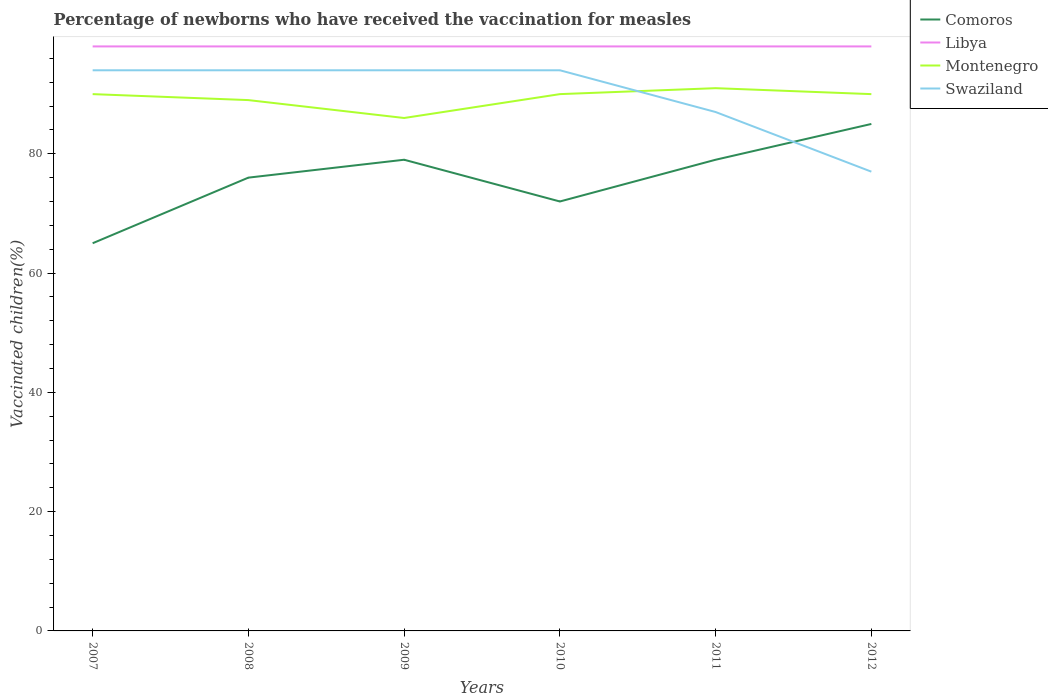How many different coloured lines are there?
Your response must be concise. 4. Across all years, what is the maximum percentage of vaccinated children in Montenegro?
Provide a short and direct response. 86. What is the total percentage of vaccinated children in Libya in the graph?
Your answer should be very brief. 0. What is the difference between the highest and the lowest percentage of vaccinated children in Montenegro?
Make the answer very short. 4. Is the percentage of vaccinated children in Montenegro strictly greater than the percentage of vaccinated children in Comoros over the years?
Provide a short and direct response. No. How many lines are there?
Make the answer very short. 4. How many years are there in the graph?
Provide a short and direct response. 6. What is the difference between two consecutive major ticks on the Y-axis?
Make the answer very short. 20. Are the values on the major ticks of Y-axis written in scientific E-notation?
Your answer should be very brief. No. Where does the legend appear in the graph?
Provide a succinct answer. Top right. How many legend labels are there?
Your response must be concise. 4. What is the title of the graph?
Provide a succinct answer. Percentage of newborns who have received the vaccination for measles. Does "Kiribati" appear as one of the legend labels in the graph?
Ensure brevity in your answer.  No. What is the label or title of the X-axis?
Offer a very short reply. Years. What is the label or title of the Y-axis?
Make the answer very short. Vaccinated children(%). What is the Vaccinated children(%) in Comoros in 2007?
Your answer should be very brief. 65. What is the Vaccinated children(%) in Libya in 2007?
Offer a terse response. 98. What is the Vaccinated children(%) of Swaziland in 2007?
Keep it short and to the point. 94. What is the Vaccinated children(%) in Montenegro in 2008?
Ensure brevity in your answer.  89. What is the Vaccinated children(%) in Swaziland in 2008?
Your response must be concise. 94. What is the Vaccinated children(%) in Comoros in 2009?
Your response must be concise. 79. What is the Vaccinated children(%) in Montenegro in 2009?
Your response must be concise. 86. What is the Vaccinated children(%) of Swaziland in 2009?
Your response must be concise. 94. What is the Vaccinated children(%) of Montenegro in 2010?
Offer a very short reply. 90. What is the Vaccinated children(%) in Swaziland in 2010?
Ensure brevity in your answer.  94. What is the Vaccinated children(%) of Comoros in 2011?
Your answer should be very brief. 79. What is the Vaccinated children(%) in Libya in 2011?
Give a very brief answer. 98. What is the Vaccinated children(%) in Montenegro in 2011?
Offer a terse response. 91. What is the Vaccinated children(%) of Swaziland in 2011?
Offer a terse response. 87. What is the Vaccinated children(%) in Comoros in 2012?
Offer a terse response. 85. What is the Vaccinated children(%) of Montenegro in 2012?
Provide a short and direct response. 90. Across all years, what is the maximum Vaccinated children(%) in Comoros?
Your response must be concise. 85. Across all years, what is the maximum Vaccinated children(%) in Montenegro?
Offer a terse response. 91. Across all years, what is the maximum Vaccinated children(%) in Swaziland?
Give a very brief answer. 94. Across all years, what is the minimum Vaccinated children(%) of Comoros?
Your response must be concise. 65. Across all years, what is the minimum Vaccinated children(%) of Libya?
Offer a terse response. 98. Across all years, what is the minimum Vaccinated children(%) of Montenegro?
Your response must be concise. 86. What is the total Vaccinated children(%) of Comoros in the graph?
Keep it short and to the point. 456. What is the total Vaccinated children(%) in Libya in the graph?
Your answer should be very brief. 588. What is the total Vaccinated children(%) in Montenegro in the graph?
Offer a very short reply. 536. What is the total Vaccinated children(%) of Swaziland in the graph?
Your answer should be compact. 540. What is the difference between the Vaccinated children(%) of Libya in 2007 and that in 2008?
Offer a very short reply. 0. What is the difference between the Vaccinated children(%) of Montenegro in 2007 and that in 2008?
Provide a short and direct response. 1. What is the difference between the Vaccinated children(%) of Libya in 2007 and that in 2009?
Provide a succinct answer. 0. What is the difference between the Vaccinated children(%) in Comoros in 2007 and that in 2011?
Your response must be concise. -14. What is the difference between the Vaccinated children(%) of Libya in 2007 and that in 2011?
Provide a succinct answer. 0. What is the difference between the Vaccinated children(%) in Swaziland in 2007 and that in 2011?
Your answer should be very brief. 7. What is the difference between the Vaccinated children(%) of Libya in 2007 and that in 2012?
Your answer should be very brief. 0. What is the difference between the Vaccinated children(%) in Montenegro in 2007 and that in 2012?
Make the answer very short. 0. What is the difference between the Vaccinated children(%) in Comoros in 2008 and that in 2009?
Make the answer very short. -3. What is the difference between the Vaccinated children(%) in Libya in 2008 and that in 2009?
Keep it short and to the point. 0. What is the difference between the Vaccinated children(%) of Montenegro in 2008 and that in 2009?
Offer a very short reply. 3. What is the difference between the Vaccinated children(%) of Swaziland in 2008 and that in 2009?
Provide a short and direct response. 0. What is the difference between the Vaccinated children(%) of Libya in 2008 and that in 2010?
Offer a terse response. 0. What is the difference between the Vaccinated children(%) of Montenegro in 2008 and that in 2010?
Make the answer very short. -1. What is the difference between the Vaccinated children(%) in Montenegro in 2008 and that in 2011?
Your answer should be compact. -2. What is the difference between the Vaccinated children(%) in Swaziland in 2008 and that in 2011?
Make the answer very short. 7. What is the difference between the Vaccinated children(%) of Libya in 2008 and that in 2012?
Provide a short and direct response. 0. What is the difference between the Vaccinated children(%) in Montenegro in 2008 and that in 2012?
Keep it short and to the point. -1. What is the difference between the Vaccinated children(%) in Libya in 2009 and that in 2010?
Provide a short and direct response. 0. What is the difference between the Vaccinated children(%) of Montenegro in 2009 and that in 2010?
Offer a terse response. -4. What is the difference between the Vaccinated children(%) of Swaziland in 2009 and that in 2010?
Make the answer very short. 0. What is the difference between the Vaccinated children(%) of Comoros in 2009 and that in 2011?
Your answer should be compact. 0. What is the difference between the Vaccinated children(%) of Libya in 2009 and that in 2011?
Provide a short and direct response. 0. What is the difference between the Vaccinated children(%) of Montenegro in 2009 and that in 2011?
Your answer should be very brief. -5. What is the difference between the Vaccinated children(%) in Montenegro in 2009 and that in 2012?
Keep it short and to the point. -4. What is the difference between the Vaccinated children(%) of Comoros in 2010 and that in 2011?
Offer a very short reply. -7. What is the difference between the Vaccinated children(%) in Libya in 2010 and that in 2011?
Your answer should be compact. 0. What is the difference between the Vaccinated children(%) of Swaziland in 2010 and that in 2012?
Keep it short and to the point. 17. What is the difference between the Vaccinated children(%) in Libya in 2011 and that in 2012?
Give a very brief answer. 0. What is the difference between the Vaccinated children(%) in Montenegro in 2011 and that in 2012?
Offer a terse response. 1. What is the difference between the Vaccinated children(%) of Swaziland in 2011 and that in 2012?
Your response must be concise. 10. What is the difference between the Vaccinated children(%) of Comoros in 2007 and the Vaccinated children(%) of Libya in 2008?
Your answer should be compact. -33. What is the difference between the Vaccinated children(%) of Comoros in 2007 and the Vaccinated children(%) of Montenegro in 2008?
Keep it short and to the point. -24. What is the difference between the Vaccinated children(%) in Comoros in 2007 and the Vaccinated children(%) in Swaziland in 2008?
Offer a terse response. -29. What is the difference between the Vaccinated children(%) in Libya in 2007 and the Vaccinated children(%) in Swaziland in 2008?
Make the answer very short. 4. What is the difference between the Vaccinated children(%) of Montenegro in 2007 and the Vaccinated children(%) of Swaziland in 2008?
Provide a short and direct response. -4. What is the difference between the Vaccinated children(%) in Comoros in 2007 and the Vaccinated children(%) in Libya in 2009?
Your answer should be compact. -33. What is the difference between the Vaccinated children(%) of Comoros in 2007 and the Vaccinated children(%) of Montenegro in 2009?
Keep it short and to the point. -21. What is the difference between the Vaccinated children(%) in Comoros in 2007 and the Vaccinated children(%) in Libya in 2010?
Ensure brevity in your answer.  -33. What is the difference between the Vaccinated children(%) in Comoros in 2007 and the Vaccinated children(%) in Montenegro in 2010?
Provide a short and direct response. -25. What is the difference between the Vaccinated children(%) in Comoros in 2007 and the Vaccinated children(%) in Swaziland in 2010?
Offer a very short reply. -29. What is the difference between the Vaccinated children(%) of Libya in 2007 and the Vaccinated children(%) of Swaziland in 2010?
Your response must be concise. 4. What is the difference between the Vaccinated children(%) of Montenegro in 2007 and the Vaccinated children(%) of Swaziland in 2010?
Provide a short and direct response. -4. What is the difference between the Vaccinated children(%) of Comoros in 2007 and the Vaccinated children(%) of Libya in 2011?
Your answer should be very brief. -33. What is the difference between the Vaccinated children(%) in Comoros in 2007 and the Vaccinated children(%) in Swaziland in 2011?
Your response must be concise. -22. What is the difference between the Vaccinated children(%) of Libya in 2007 and the Vaccinated children(%) of Swaziland in 2011?
Keep it short and to the point. 11. What is the difference between the Vaccinated children(%) in Montenegro in 2007 and the Vaccinated children(%) in Swaziland in 2011?
Give a very brief answer. 3. What is the difference between the Vaccinated children(%) in Comoros in 2007 and the Vaccinated children(%) in Libya in 2012?
Make the answer very short. -33. What is the difference between the Vaccinated children(%) in Comoros in 2007 and the Vaccinated children(%) in Swaziland in 2012?
Provide a succinct answer. -12. What is the difference between the Vaccinated children(%) of Libya in 2007 and the Vaccinated children(%) of Montenegro in 2012?
Provide a short and direct response. 8. What is the difference between the Vaccinated children(%) in Libya in 2008 and the Vaccinated children(%) in Montenegro in 2009?
Provide a short and direct response. 12. What is the difference between the Vaccinated children(%) in Libya in 2008 and the Vaccinated children(%) in Swaziland in 2009?
Your answer should be compact. 4. What is the difference between the Vaccinated children(%) in Montenegro in 2008 and the Vaccinated children(%) in Swaziland in 2009?
Offer a terse response. -5. What is the difference between the Vaccinated children(%) of Comoros in 2008 and the Vaccinated children(%) of Montenegro in 2010?
Your response must be concise. -14. What is the difference between the Vaccinated children(%) in Libya in 2008 and the Vaccinated children(%) in Montenegro in 2010?
Keep it short and to the point. 8. What is the difference between the Vaccinated children(%) of Montenegro in 2008 and the Vaccinated children(%) of Swaziland in 2010?
Offer a very short reply. -5. What is the difference between the Vaccinated children(%) of Comoros in 2008 and the Vaccinated children(%) of Libya in 2011?
Your response must be concise. -22. What is the difference between the Vaccinated children(%) of Comoros in 2008 and the Vaccinated children(%) of Swaziland in 2011?
Provide a short and direct response. -11. What is the difference between the Vaccinated children(%) in Libya in 2008 and the Vaccinated children(%) in Montenegro in 2011?
Your response must be concise. 7. What is the difference between the Vaccinated children(%) in Libya in 2008 and the Vaccinated children(%) in Swaziland in 2011?
Your response must be concise. 11. What is the difference between the Vaccinated children(%) in Montenegro in 2008 and the Vaccinated children(%) in Swaziland in 2011?
Your response must be concise. 2. What is the difference between the Vaccinated children(%) of Comoros in 2008 and the Vaccinated children(%) of Libya in 2012?
Your answer should be very brief. -22. What is the difference between the Vaccinated children(%) of Comoros in 2008 and the Vaccinated children(%) of Montenegro in 2012?
Offer a very short reply. -14. What is the difference between the Vaccinated children(%) of Montenegro in 2008 and the Vaccinated children(%) of Swaziland in 2012?
Your response must be concise. 12. What is the difference between the Vaccinated children(%) in Comoros in 2009 and the Vaccinated children(%) in Libya in 2010?
Ensure brevity in your answer.  -19. What is the difference between the Vaccinated children(%) of Comoros in 2009 and the Vaccinated children(%) of Swaziland in 2010?
Provide a short and direct response. -15. What is the difference between the Vaccinated children(%) in Libya in 2009 and the Vaccinated children(%) in Swaziland in 2010?
Make the answer very short. 4. What is the difference between the Vaccinated children(%) in Comoros in 2009 and the Vaccinated children(%) in Libya in 2011?
Keep it short and to the point. -19. What is the difference between the Vaccinated children(%) of Comoros in 2009 and the Vaccinated children(%) of Swaziland in 2011?
Offer a terse response. -8. What is the difference between the Vaccinated children(%) of Libya in 2009 and the Vaccinated children(%) of Montenegro in 2011?
Make the answer very short. 7. What is the difference between the Vaccinated children(%) in Libya in 2009 and the Vaccinated children(%) in Swaziland in 2011?
Provide a succinct answer. 11. What is the difference between the Vaccinated children(%) of Montenegro in 2009 and the Vaccinated children(%) of Swaziland in 2011?
Your response must be concise. -1. What is the difference between the Vaccinated children(%) of Comoros in 2009 and the Vaccinated children(%) of Libya in 2012?
Your answer should be very brief. -19. What is the difference between the Vaccinated children(%) of Comoros in 2009 and the Vaccinated children(%) of Swaziland in 2012?
Give a very brief answer. 2. What is the difference between the Vaccinated children(%) in Libya in 2009 and the Vaccinated children(%) in Montenegro in 2012?
Your answer should be compact. 8. What is the difference between the Vaccinated children(%) in Montenegro in 2009 and the Vaccinated children(%) in Swaziland in 2012?
Provide a succinct answer. 9. What is the difference between the Vaccinated children(%) of Comoros in 2010 and the Vaccinated children(%) of Libya in 2011?
Your answer should be very brief. -26. What is the difference between the Vaccinated children(%) of Comoros in 2010 and the Vaccinated children(%) of Montenegro in 2011?
Ensure brevity in your answer.  -19. What is the difference between the Vaccinated children(%) of Comoros in 2010 and the Vaccinated children(%) of Libya in 2012?
Provide a succinct answer. -26. What is the difference between the Vaccinated children(%) of Comoros in 2010 and the Vaccinated children(%) of Swaziland in 2012?
Your answer should be very brief. -5. What is the difference between the Vaccinated children(%) in Libya in 2010 and the Vaccinated children(%) in Montenegro in 2012?
Ensure brevity in your answer.  8. What is the difference between the Vaccinated children(%) in Comoros in 2011 and the Vaccinated children(%) in Libya in 2012?
Your answer should be very brief. -19. What is the difference between the Vaccinated children(%) of Comoros in 2011 and the Vaccinated children(%) of Swaziland in 2012?
Your answer should be compact. 2. What is the difference between the Vaccinated children(%) in Libya in 2011 and the Vaccinated children(%) in Montenegro in 2012?
Provide a succinct answer. 8. What is the difference between the Vaccinated children(%) in Libya in 2011 and the Vaccinated children(%) in Swaziland in 2012?
Give a very brief answer. 21. What is the difference between the Vaccinated children(%) in Montenegro in 2011 and the Vaccinated children(%) in Swaziland in 2012?
Provide a succinct answer. 14. What is the average Vaccinated children(%) of Libya per year?
Give a very brief answer. 98. What is the average Vaccinated children(%) in Montenegro per year?
Your answer should be very brief. 89.33. In the year 2007, what is the difference between the Vaccinated children(%) of Comoros and Vaccinated children(%) of Libya?
Provide a succinct answer. -33. In the year 2007, what is the difference between the Vaccinated children(%) of Comoros and Vaccinated children(%) of Montenegro?
Keep it short and to the point. -25. In the year 2007, what is the difference between the Vaccinated children(%) in Montenegro and Vaccinated children(%) in Swaziland?
Your response must be concise. -4. In the year 2008, what is the difference between the Vaccinated children(%) of Libya and Vaccinated children(%) of Montenegro?
Your answer should be compact. 9. In the year 2008, what is the difference between the Vaccinated children(%) of Libya and Vaccinated children(%) of Swaziland?
Your answer should be compact. 4. In the year 2008, what is the difference between the Vaccinated children(%) in Montenegro and Vaccinated children(%) in Swaziland?
Offer a very short reply. -5. In the year 2009, what is the difference between the Vaccinated children(%) of Comoros and Vaccinated children(%) of Libya?
Provide a short and direct response. -19. In the year 2009, what is the difference between the Vaccinated children(%) in Comoros and Vaccinated children(%) in Montenegro?
Offer a terse response. -7. In the year 2009, what is the difference between the Vaccinated children(%) of Comoros and Vaccinated children(%) of Swaziland?
Make the answer very short. -15. In the year 2009, what is the difference between the Vaccinated children(%) in Montenegro and Vaccinated children(%) in Swaziland?
Your answer should be very brief. -8. In the year 2010, what is the difference between the Vaccinated children(%) of Comoros and Vaccinated children(%) of Libya?
Your answer should be very brief. -26. In the year 2010, what is the difference between the Vaccinated children(%) of Comoros and Vaccinated children(%) of Swaziland?
Keep it short and to the point. -22. In the year 2010, what is the difference between the Vaccinated children(%) of Montenegro and Vaccinated children(%) of Swaziland?
Offer a terse response. -4. In the year 2011, what is the difference between the Vaccinated children(%) in Comoros and Vaccinated children(%) in Montenegro?
Offer a very short reply. -12. In the year 2011, what is the difference between the Vaccinated children(%) in Libya and Vaccinated children(%) in Montenegro?
Your response must be concise. 7. In the year 2011, what is the difference between the Vaccinated children(%) of Libya and Vaccinated children(%) of Swaziland?
Provide a short and direct response. 11. In the year 2011, what is the difference between the Vaccinated children(%) in Montenegro and Vaccinated children(%) in Swaziland?
Provide a short and direct response. 4. In the year 2012, what is the difference between the Vaccinated children(%) of Comoros and Vaccinated children(%) of Libya?
Provide a succinct answer. -13. In the year 2012, what is the difference between the Vaccinated children(%) of Comoros and Vaccinated children(%) of Montenegro?
Offer a very short reply. -5. In the year 2012, what is the difference between the Vaccinated children(%) in Libya and Vaccinated children(%) in Montenegro?
Offer a very short reply. 8. What is the ratio of the Vaccinated children(%) of Comoros in 2007 to that in 2008?
Make the answer very short. 0.86. What is the ratio of the Vaccinated children(%) of Libya in 2007 to that in 2008?
Offer a terse response. 1. What is the ratio of the Vaccinated children(%) in Montenegro in 2007 to that in 2008?
Keep it short and to the point. 1.01. What is the ratio of the Vaccinated children(%) in Comoros in 2007 to that in 2009?
Provide a succinct answer. 0.82. What is the ratio of the Vaccinated children(%) in Montenegro in 2007 to that in 2009?
Provide a succinct answer. 1.05. What is the ratio of the Vaccinated children(%) in Swaziland in 2007 to that in 2009?
Your response must be concise. 1. What is the ratio of the Vaccinated children(%) in Comoros in 2007 to that in 2010?
Provide a short and direct response. 0.9. What is the ratio of the Vaccinated children(%) in Comoros in 2007 to that in 2011?
Your response must be concise. 0.82. What is the ratio of the Vaccinated children(%) of Swaziland in 2007 to that in 2011?
Your answer should be very brief. 1.08. What is the ratio of the Vaccinated children(%) in Comoros in 2007 to that in 2012?
Your answer should be very brief. 0.76. What is the ratio of the Vaccinated children(%) of Swaziland in 2007 to that in 2012?
Your answer should be very brief. 1.22. What is the ratio of the Vaccinated children(%) of Comoros in 2008 to that in 2009?
Offer a very short reply. 0.96. What is the ratio of the Vaccinated children(%) of Libya in 2008 to that in 2009?
Your answer should be very brief. 1. What is the ratio of the Vaccinated children(%) of Montenegro in 2008 to that in 2009?
Offer a terse response. 1.03. What is the ratio of the Vaccinated children(%) of Swaziland in 2008 to that in 2009?
Offer a very short reply. 1. What is the ratio of the Vaccinated children(%) in Comoros in 2008 to that in 2010?
Provide a succinct answer. 1.06. What is the ratio of the Vaccinated children(%) of Montenegro in 2008 to that in 2010?
Keep it short and to the point. 0.99. What is the ratio of the Vaccinated children(%) of Libya in 2008 to that in 2011?
Your response must be concise. 1. What is the ratio of the Vaccinated children(%) of Swaziland in 2008 to that in 2011?
Your response must be concise. 1.08. What is the ratio of the Vaccinated children(%) of Comoros in 2008 to that in 2012?
Offer a terse response. 0.89. What is the ratio of the Vaccinated children(%) in Montenegro in 2008 to that in 2012?
Give a very brief answer. 0.99. What is the ratio of the Vaccinated children(%) in Swaziland in 2008 to that in 2012?
Provide a short and direct response. 1.22. What is the ratio of the Vaccinated children(%) in Comoros in 2009 to that in 2010?
Your response must be concise. 1.1. What is the ratio of the Vaccinated children(%) in Libya in 2009 to that in 2010?
Make the answer very short. 1. What is the ratio of the Vaccinated children(%) in Montenegro in 2009 to that in 2010?
Your response must be concise. 0.96. What is the ratio of the Vaccinated children(%) of Libya in 2009 to that in 2011?
Offer a terse response. 1. What is the ratio of the Vaccinated children(%) in Montenegro in 2009 to that in 2011?
Provide a succinct answer. 0.95. What is the ratio of the Vaccinated children(%) in Swaziland in 2009 to that in 2011?
Your response must be concise. 1.08. What is the ratio of the Vaccinated children(%) in Comoros in 2009 to that in 2012?
Keep it short and to the point. 0.93. What is the ratio of the Vaccinated children(%) in Montenegro in 2009 to that in 2012?
Your answer should be compact. 0.96. What is the ratio of the Vaccinated children(%) of Swaziland in 2009 to that in 2012?
Make the answer very short. 1.22. What is the ratio of the Vaccinated children(%) in Comoros in 2010 to that in 2011?
Make the answer very short. 0.91. What is the ratio of the Vaccinated children(%) of Libya in 2010 to that in 2011?
Ensure brevity in your answer.  1. What is the ratio of the Vaccinated children(%) of Swaziland in 2010 to that in 2011?
Your answer should be very brief. 1.08. What is the ratio of the Vaccinated children(%) in Comoros in 2010 to that in 2012?
Offer a terse response. 0.85. What is the ratio of the Vaccinated children(%) of Montenegro in 2010 to that in 2012?
Give a very brief answer. 1. What is the ratio of the Vaccinated children(%) of Swaziland in 2010 to that in 2012?
Your response must be concise. 1.22. What is the ratio of the Vaccinated children(%) of Comoros in 2011 to that in 2012?
Provide a succinct answer. 0.93. What is the ratio of the Vaccinated children(%) of Montenegro in 2011 to that in 2012?
Provide a succinct answer. 1.01. What is the ratio of the Vaccinated children(%) of Swaziland in 2011 to that in 2012?
Provide a succinct answer. 1.13. What is the difference between the highest and the second highest Vaccinated children(%) in Comoros?
Provide a succinct answer. 6. What is the difference between the highest and the lowest Vaccinated children(%) of Comoros?
Offer a very short reply. 20. What is the difference between the highest and the lowest Vaccinated children(%) of Montenegro?
Your response must be concise. 5. What is the difference between the highest and the lowest Vaccinated children(%) of Swaziland?
Your response must be concise. 17. 